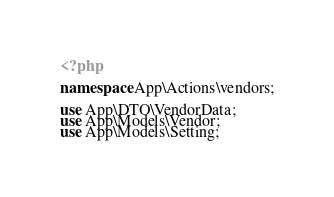Convert code to text. <code><loc_0><loc_0><loc_500><loc_500><_PHP_><?php

namespace App\Actions\vendors;

use App\DTO\VendorData;
use App\Models\Vendor;
use App\Models\Setting;</code> 